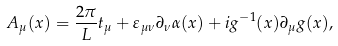Convert formula to latex. <formula><loc_0><loc_0><loc_500><loc_500>A _ { \mu } ( x ) = \frac { 2 \pi } { L } t _ { \mu } + \varepsilon _ { \mu \nu } \partial _ { \nu } \alpha ( x ) + i g ^ { - 1 } ( x ) \partial _ { \mu } g ( x ) ,</formula> 